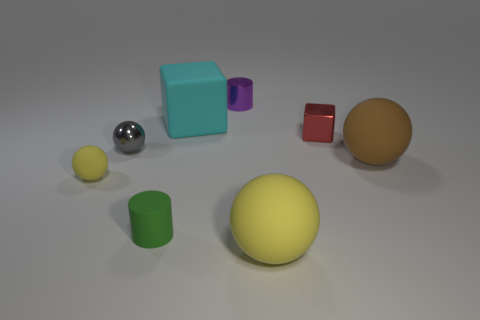How can the lighting and shadows in this image inform us about the environment in which these objects are placed? The shadows cast by the objects in the image are soft and suggest a diffuse light source, possibly imitating an overcast sky or a soft-box light in a studio setting. There's a consistency in the shadow direction, indicating a single primary light source. The evenness of the lighting and soft shadows contribute to the calm and controlled atmosphere of the scene, typical of an indoor studio setup. 